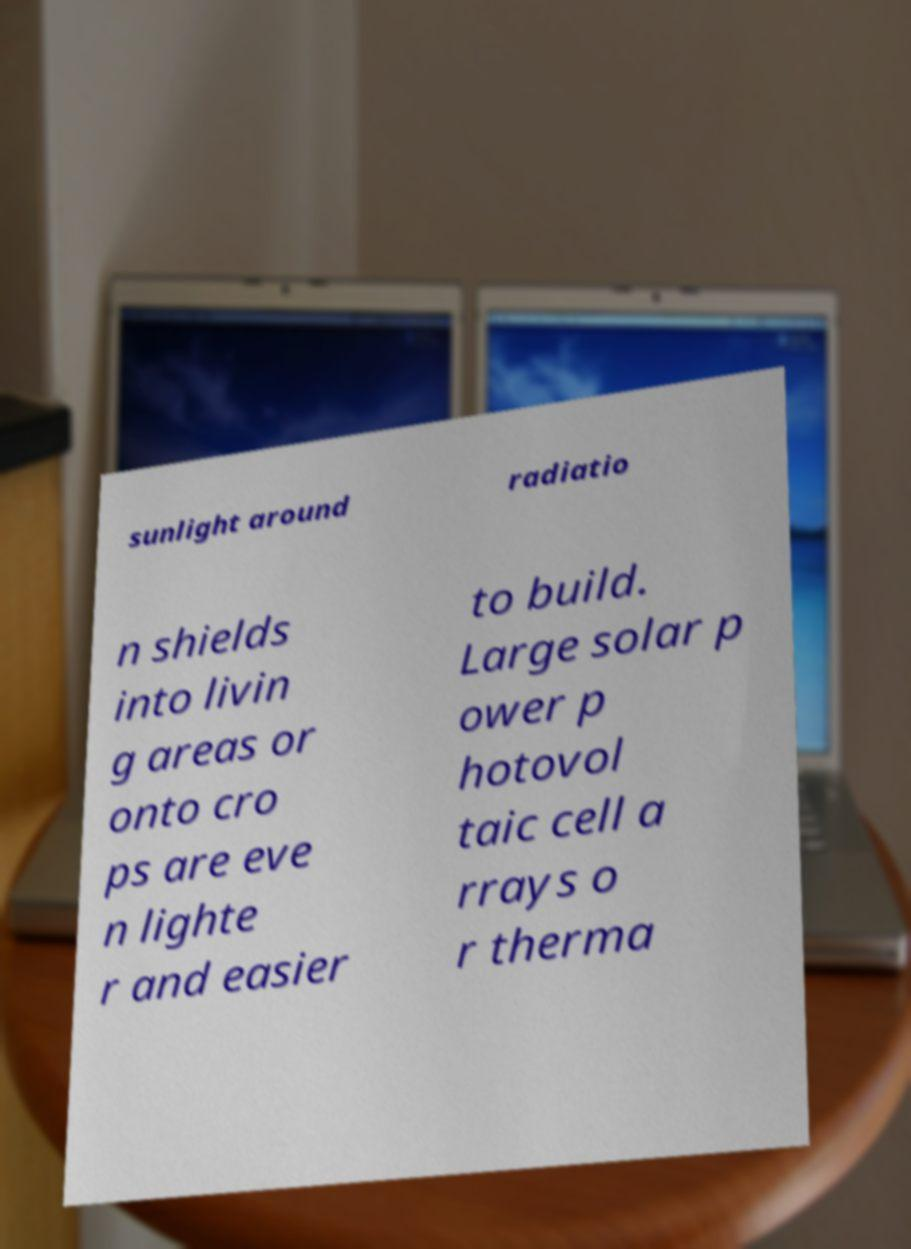Please identify and transcribe the text found in this image. sunlight around radiatio n shields into livin g areas or onto cro ps are eve n lighte r and easier to build. Large solar p ower p hotovol taic cell a rrays o r therma 